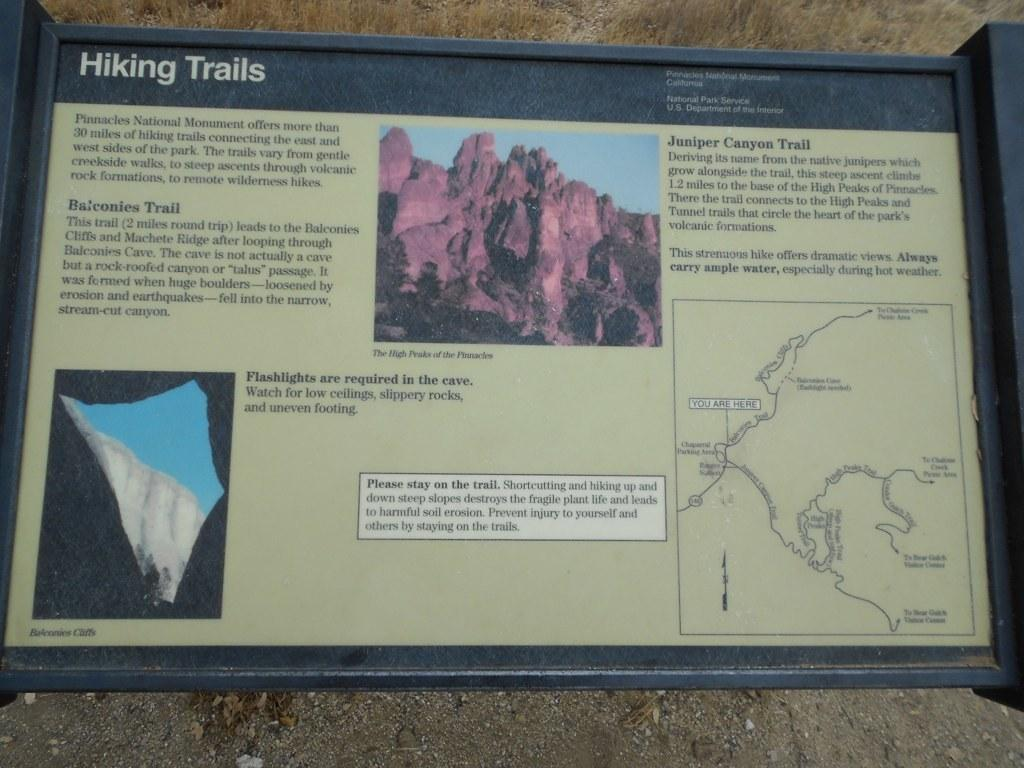<image>
Relay a brief, clear account of the picture shown. Information for hiking trails at Pinnacles National Monument instructs hikers to stay on the trail. 